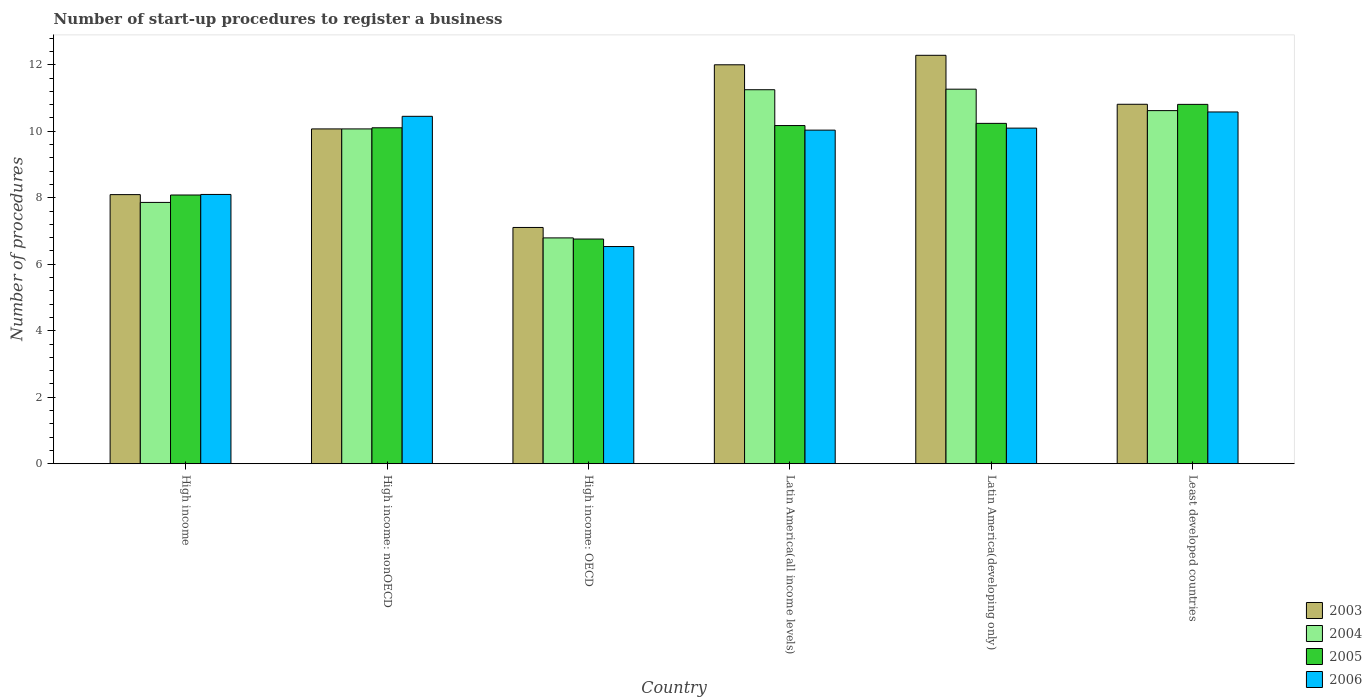How many groups of bars are there?
Offer a terse response. 6. Are the number of bars on each tick of the X-axis equal?
Ensure brevity in your answer.  Yes. How many bars are there on the 5th tick from the left?
Make the answer very short. 4. How many bars are there on the 2nd tick from the right?
Your answer should be very brief. 4. What is the label of the 1st group of bars from the left?
Offer a very short reply. High income. What is the number of procedures required to register a business in 2004 in Latin America(all income levels)?
Give a very brief answer. 11.25. Across all countries, what is the maximum number of procedures required to register a business in 2004?
Your response must be concise. 11.27. Across all countries, what is the minimum number of procedures required to register a business in 2003?
Provide a succinct answer. 7.11. In which country was the number of procedures required to register a business in 2003 maximum?
Provide a short and direct response. Latin America(developing only). In which country was the number of procedures required to register a business in 2003 minimum?
Make the answer very short. High income: OECD. What is the total number of procedures required to register a business in 2004 in the graph?
Offer a very short reply. 57.86. What is the difference between the number of procedures required to register a business in 2004 in High income: nonOECD and that in Least developed countries?
Make the answer very short. -0.55. What is the difference between the number of procedures required to register a business in 2004 in High income: nonOECD and the number of procedures required to register a business in 2003 in Latin America(developing only)?
Your answer should be compact. -2.21. What is the average number of procedures required to register a business in 2003 per country?
Give a very brief answer. 10.06. What is the difference between the number of procedures required to register a business of/in 2003 and number of procedures required to register a business of/in 2004 in High income: OECD?
Your response must be concise. 0.31. What is the ratio of the number of procedures required to register a business in 2003 in Latin America(developing only) to that in Least developed countries?
Offer a terse response. 1.14. What is the difference between the highest and the second highest number of procedures required to register a business in 2006?
Make the answer very short. 0.13. What is the difference between the highest and the lowest number of procedures required to register a business in 2003?
Your answer should be compact. 5.18. In how many countries, is the number of procedures required to register a business in 2004 greater than the average number of procedures required to register a business in 2004 taken over all countries?
Provide a short and direct response. 4. Is the sum of the number of procedures required to register a business in 2005 in High income and High income: OECD greater than the maximum number of procedures required to register a business in 2004 across all countries?
Ensure brevity in your answer.  Yes. What does the 2nd bar from the left in High income: nonOECD represents?
Your answer should be very brief. 2004. Are all the bars in the graph horizontal?
Make the answer very short. No. How many countries are there in the graph?
Provide a short and direct response. 6. What is the difference between two consecutive major ticks on the Y-axis?
Keep it short and to the point. 2. Are the values on the major ticks of Y-axis written in scientific E-notation?
Ensure brevity in your answer.  No. Does the graph contain any zero values?
Provide a short and direct response. No. Where does the legend appear in the graph?
Your answer should be very brief. Bottom right. How many legend labels are there?
Your answer should be compact. 4. What is the title of the graph?
Offer a very short reply. Number of start-up procedures to register a business. Does "1961" appear as one of the legend labels in the graph?
Your response must be concise. No. What is the label or title of the X-axis?
Make the answer very short. Country. What is the label or title of the Y-axis?
Your answer should be compact. Number of procedures. What is the Number of procedures of 2003 in High income?
Offer a very short reply. 8.1. What is the Number of procedures of 2004 in High income?
Keep it short and to the point. 7.86. What is the Number of procedures in 2005 in High income?
Provide a succinct answer. 8.08. What is the Number of procedures in 2006 in High income?
Offer a terse response. 8.1. What is the Number of procedures of 2003 in High income: nonOECD?
Ensure brevity in your answer.  10.07. What is the Number of procedures in 2004 in High income: nonOECD?
Ensure brevity in your answer.  10.07. What is the Number of procedures of 2005 in High income: nonOECD?
Keep it short and to the point. 10.11. What is the Number of procedures in 2006 in High income: nonOECD?
Give a very brief answer. 10.45. What is the Number of procedures in 2003 in High income: OECD?
Provide a succinct answer. 7.11. What is the Number of procedures of 2004 in High income: OECD?
Ensure brevity in your answer.  6.79. What is the Number of procedures in 2005 in High income: OECD?
Provide a short and direct response. 6.76. What is the Number of procedures in 2006 in High income: OECD?
Provide a succinct answer. 6.53. What is the Number of procedures in 2003 in Latin America(all income levels)?
Provide a succinct answer. 12. What is the Number of procedures of 2004 in Latin America(all income levels)?
Provide a succinct answer. 11.25. What is the Number of procedures in 2005 in Latin America(all income levels)?
Your response must be concise. 10.17. What is the Number of procedures in 2006 in Latin America(all income levels)?
Keep it short and to the point. 10.03. What is the Number of procedures of 2003 in Latin America(developing only)?
Your answer should be compact. 12.29. What is the Number of procedures of 2004 in Latin America(developing only)?
Keep it short and to the point. 11.27. What is the Number of procedures of 2005 in Latin America(developing only)?
Keep it short and to the point. 10.24. What is the Number of procedures of 2006 in Latin America(developing only)?
Keep it short and to the point. 10.1. What is the Number of procedures in 2003 in Least developed countries?
Offer a terse response. 10.81. What is the Number of procedures in 2004 in Least developed countries?
Make the answer very short. 10.62. What is the Number of procedures of 2005 in Least developed countries?
Provide a short and direct response. 10.81. What is the Number of procedures in 2006 in Least developed countries?
Provide a short and direct response. 10.58. Across all countries, what is the maximum Number of procedures of 2003?
Provide a succinct answer. 12.29. Across all countries, what is the maximum Number of procedures of 2004?
Keep it short and to the point. 11.27. Across all countries, what is the maximum Number of procedures of 2005?
Give a very brief answer. 10.81. Across all countries, what is the maximum Number of procedures in 2006?
Offer a very short reply. 10.58. Across all countries, what is the minimum Number of procedures in 2003?
Your answer should be compact. 7.11. Across all countries, what is the minimum Number of procedures in 2004?
Offer a very short reply. 6.79. Across all countries, what is the minimum Number of procedures in 2005?
Provide a short and direct response. 6.76. Across all countries, what is the minimum Number of procedures in 2006?
Provide a succinct answer. 6.53. What is the total Number of procedures of 2003 in the graph?
Provide a succinct answer. 60.37. What is the total Number of procedures in 2004 in the graph?
Offer a very short reply. 57.86. What is the total Number of procedures in 2005 in the graph?
Your response must be concise. 56.17. What is the total Number of procedures in 2006 in the graph?
Make the answer very short. 55.79. What is the difference between the Number of procedures in 2003 in High income and that in High income: nonOECD?
Offer a terse response. -1.98. What is the difference between the Number of procedures of 2004 in High income and that in High income: nonOECD?
Your answer should be very brief. -2.21. What is the difference between the Number of procedures of 2005 in High income and that in High income: nonOECD?
Provide a short and direct response. -2.02. What is the difference between the Number of procedures of 2006 in High income and that in High income: nonOECD?
Your answer should be very brief. -2.35. What is the difference between the Number of procedures in 2004 in High income and that in High income: OECD?
Offer a terse response. 1.07. What is the difference between the Number of procedures of 2005 in High income and that in High income: OECD?
Provide a short and direct response. 1.32. What is the difference between the Number of procedures in 2006 in High income and that in High income: OECD?
Your response must be concise. 1.57. What is the difference between the Number of procedures in 2003 in High income and that in Latin America(all income levels)?
Your response must be concise. -3.9. What is the difference between the Number of procedures in 2004 in High income and that in Latin America(all income levels)?
Offer a very short reply. -3.39. What is the difference between the Number of procedures of 2005 in High income and that in Latin America(all income levels)?
Give a very brief answer. -2.09. What is the difference between the Number of procedures in 2006 in High income and that in Latin America(all income levels)?
Give a very brief answer. -1.93. What is the difference between the Number of procedures in 2003 in High income and that in Latin America(developing only)?
Give a very brief answer. -4.19. What is the difference between the Number of procedures of 2004 in High income and that in Latin America(developing only)?
Make the answer very short. -3.41. What is the difference between the Number of procedures in 2005 in High income and that in Latin America(developing only)?
Make the answer very short. -2.15. What is the difference between the Number of procedures of 2006 in High income and that in Latin America(developing only)?
Your answer should be compact. -2. What is the difference between the Number of procedures in 2003 in High income and that in Least developed countries?
Provide a short and direct response. -2.72. What is the difference between the Number of procedures in 2004 in High income and that in Least developed countries?
Your answer should be very brief. -2.76. What is the difference between the Number of procedures of 2005 in High income and that in Least developed countries?
Provide a succinct answer. -2.73. What is the difference between the Number of procedures of 2006 in High income and that in Least developed countries?
Ensure brevity in your answer.  -2.48. What is the difference between the Number of procedures of 2003 in High income: nonOECD and that in High income: OECD?
Provide a short and direct response. 2.96. What is the difference between the Number of procedures in 2004 in High income: nonOECD and that in High income: OECD?
Offer a terse response. 3.28. What is the difference between the Number of procedures of 2005 in High income: nonOECD and that in High income: OECD?
Your answer should be very brief. 3.35. What is the difference between the Number of procedures in 2006 in High income: nonOECD and that in High income: OECD?
Offer a terse response. 3.92. What is the difference between the Number of procedures in 2003 in High income: nonOECD and that in Latin America(all income levels)?
Offer a very short reply. -1.93. What is the difference between the Number of procedures of 2004 in High income: nonOECD and that in Latin America(all income levels)?
Your answer should be compact. -1.18. What is the difference between the Number of procedures in 2005 in High income: nonOECD and that in Latin America(all income levels)?
Your answer should be compact. -0.07. What is the difference between the Number of procedures of 2006 in High income: nonOECD and that in Latin America(all income levels)?
Give a very brief answer. 0.42. What is the difference between the Number of procedures in 2003 in High income: nonOECD and that in Latin America(developing only)?
Give a very brief answer. -2.21. What is the difference between the Number of procedures in 2004 in High income: nonOECD and that in Latin America(developing only)?
Give a very brief answer. -1.2. What is the difference between the Number of procedures of 2005 in High income: nonOECD and that in Latin America(developing only)?
Provide a succinct answer. -0.13. What is the difference between the Number of procedures of 2006 in High income: nonOECD and that in Latin America(developing only)?
Your answer should be compact. 0.35. What is the difference between the Number of procedures of 2003 in High income: nonOECD and that in Least developed countries?
Your response must be concise. -0.74. What is the difference between the Number of procedures in 2004 in High income: nonOECD and that in Least developed countries?
Make the answer very short. -0.55. What is the difference between the Number of procedures of 2005 in High income: nonOECD and that in Least developed countries?
Keep it short and to the point. -0.7. What is the difference between the Number of procedures in 2006 in High income: nonOECD and that in Least developed countries?
Provide a short and direct response. -0.13. What is the difference between the Number of procedures in 2003 in High income: OECD and that in Latin America(all income levels)?
Your response must be concise. -4.89. What is the difference between the Number of procedures in 2004 in High income: OECD and that in Latin America(all income levels)?
Your response must be concise. -4.46. What is the difference between the Number of procedures of 2005 in High income: OECD and that in Latin America(all income levels)?
Your answer should be very brief. -3.41. What is the difference between the Number of procedures of 2006 in High income: OECD and that in Latin America(all income levels)?
Your response must be concise. -3.5. What is the difference between the Number of procedures in 2003 in High income: OECD and that in Latin America(developing only)?
Provide a succinct answer. -5.18. What is the difference between the Number of procedures in 2004 in High income: OECD and that in Latin America(developing only)?
Your answer should be compact. -4.47. What is the difference between the Number of procedures in 2005 in High income: OECD and that in Latin America(developing only)?
Provide a short and direct response. -3.48. What is the difference between the Number of procedures of 2006 in High income: OECD and that in Latin America(developing only)?
Keep it short and to the point. -3.56. What is the difference between the Number of procedures in 2003 in High income: OECD and that in Least developed countries?
Your answer should be very brief. -3.71. What is the difference between the Number of procedures of 2004 in High income: OECD and that in Least developed countries?
Ensure brevity in your answer.  -3.83. What is the difference between the Number of procedures of 2005 in High income: OECD and that in Least developed countries?
Your answer should be very brief. -4.05. What is the difference between the Number of procedures in 2006 in High income: OECD and that in Least developed countries?
Provide a short and direct response. -4.05. What is the difference between the Number of procedures of 2003 in Latin America(all income levels) and that in Latin America(developing only)?
Your response must be concise. -0.29. What is the difference between the Number of procedures of 2004 in Latin America(all income levels) and that in Latin America(developing only)?
Your answer should be compact. -0.02. What is the difference between the Number of procedures of 2005 in Latin America(all income levels) and that in Latin America(developing only)?
Provide a short and direct response. -0.07. What is the difference between the Number of procedures of 2006 in Latin America(all income levels) and that in Latin America(developing only)?
Offer a very short reply. -0.06. What is the difference between the Number of procedures of 2003 in Latin America(all income levels) and that in Least developed countries?
Offer a terse response. 1.19. What is the difference between the Number of procedures in 2004 in Latin America(all income levels) and that in Least developed countries?
Provide a short and direct response. 0.63. What is the difference between the Number of procedures in 2005 in Latin America(all income levels) and that in Least developed countries?
Your response must be concise. -0.64. What is the difference between the Number of procedures of 2006 in Latin America(all income levels) and that in Least developed countries?
Make the answer very short. -0.55. What is the difference between the Number of procedures in 2003 in Latin America(developing only) and that in Least developed countries?
Ensure brevity in your answer.  1.47. What is the difference between the Number of procedures in 2004 in Latin America(developing only) and that in Least developed countries?
Provide a succinct answer. 0.65. What is the difference between the Number of procedures of 2005 in Latin America(developing only) and that in Least developed countries?
Offer a very short reply. -0.57. What is the difference between the Number of procedures of 2006 in Latin America(developing only) and that in Least developed countries?
Offer a very short reply. -0.49. What is the difference between the Number of procedures of 2003 in High income and the Number of procedures of 2004 in High income: nonOECD?
Give a very brief answer. -1.98. What is the difference between the Number of procedures of 2003 in High income and the Number of procedures of 2005 in High income: nonOECD?
Keep it short and to the point. -2.01. What is the difference between the Number of procedures of 2003 in High income and the Number of procedures of 2006 in High income: nonOECD?
Ensure brevity in your answer.  -2.35. What is the difference between the Number of procedures of 2004 in High income and the Number of procedures of 2005 in High income: nonOECD?
Your answer should be very brief. -2.24. What is the difference between the Number of procedures in 2004 in High income and the Number of procedures in 2006 in High income: nonOECD?
Provide a short and direct response. -2.59. What is the difference between the Number of procedures in 2005 in High income and the Number of procedures in 2006 in High income: nonOECD?
Provide a short and direct response. -2.37. What is the difference between the Number of procedures of 2003 in High income and the Number of procedures of 2004 in High income: OECD?
Make the answer very short. 1.3. What is the difference between the Number of procedures of 2003 in High income and the Number of procedures of 2005 in High income: OECD?
Ensure brevity in your answer.  1.34. What is the difference between the Number of procedures of 2003 in High income and the Number of procedures of 2006 in High income: OECD?
Your answer should be compact. 1.56. What is the difference between the Number of procedures of 2004 in High income and the Number of procedures of 2005 in High income: OECD?
Make the answer very short. 1.1. What is the difference between the Number of procedures in 2004 in High income and the Number of procedures in 2006 in High income: OECD?
Your answer should be compact. 1.33. What is the difference between the Number of procedures in 2005 in High income and the Number of procedures in 2006 in High income: OECD?
Ensure brevity in your answer.  1.55. What is the difference between the Number of procedures of 2003 in High income and the Number of procedures of 2004 in Latin America(all income levels)?
Your answer should be compact. -3.15. What is the difference between the Number of procedures of 2003 in High income and the Number of procedures of 2005 in Latin America(all income levels)?
Provide a short and direct response. -2.08. What is the difference between the Number of procedures in 2003 in High income and the Number of procedures in 2006 in Latin America(all income levels)?
Make the answer very short. -1.94. What is the difference between the Number of procedures in 2004 in High income and the Number of procedures in 2005 in Latin America(all income levels)?
Offer a very short reply. -2.31. What is the difference between the Number of procedures of 2004 in High income and the Number of procedures of 2006 in Latin America(all income levels)?
Keep it short and to the point. -2.17. What is the difference between the Number of procedures in 2005 in High income and the Number of procedures in 2006 in Latin America(all income levels)?
Give a very brief answer. -1.95. What is the difference between the Number of procedures of 2003 in High income and the Number of procedures of 2004 in Latin America(developing only)?
Provide a short and direct response. -3.17. What is the difference between the Number of procedures in 2003 in High income and the Number of procedures in 2005 in Latin America(developing only)?
Keep it short and to the point. -2.14. What is the difference between the Number of procedures in 2004 in High income and the Number of procedures in 2005 in Latin America(developing only)?
Your response must be concise. -2.38. What is the difference between the Number of procedures of 2004 in High income and the Number of procedures of 2006 in Latin America(developing only)?
Offer a very short reply. -2.23. What is the difference between the Number of procedures of 2005 in High income and the Number of procedures of 2006 in Latin America(developing only)?
Provide a short and direct response. -2.01. What is the difference between the Number of procedures in 2003 in High income and the Number of procedures in 2004 in Least developed countries?
Make the answer very short. -2.53. What is the difference between the Number of procedures in 2003 in High income and the Number of procedures in 2005 in Least developed countries?
Provide a succinct answer. -2.71. What is the difference between the Number of procedures in 2003 in High income and the Number of procedures in 2006 in Least developed countries?
Ensure brevity in your answer.  -2.49. What is the difference between the Number of procedures in 2004 in High income and the Number of procedures in 2005 in Least developed countries?
Your response must be concise. -2.95. What is the difference between the Number of procedures in 2004 in High income and the Number of procedures in 2006 in Least developed countries?
Keep it short and to the point. -2.72. What is the difference between the Number of procedures in 2005 in High income and the Number of procedures in 2006 in Least developed countries?
Provide a succinct answer. -2.5. What is the difference between the Number of procedures of 2003 in High income: nonOECD and the Number of procedures of 2004 in High income: OECD?
Your answer should be compact. 3.28. What is the difference between the Number of procedures in 2003 in High income: nonOECD and the Number of procedures in 2005 in High income: OECD?
Provide a succinct answer. 3.31. What is the difference between the Number of procedures in 2003 in High income: nonOECD and the Number of procedures in 2006 in High income: OECD?
Keep it short and to the point. 3.54. What is the difference between the Number of procedures of 2004 in High income: nonOECD and the Number of procedures of 2005 in High income: OECD?
Provide a short and direct response. 3.31. What is the difference between the Number of procedures of 2004 in High income: nonOECD and the Number of procedures of 2006 in High income: OECD?
Your response must be concise. 3.54. What is the difference between the Number of procedures of 2005 in High income: nonOECD and the Number of procedures of 2006 in High income: OECD?
Keep it short and to the point. 3.57. What is the difference between the Number of procedures of 2003 in High income: nonOECD and the Number of procedures of 2004 in Latin America(all income levels)?
Your answer should be compact. -1.18. What is the difference between the Number of procedures in 2003 in High income: nonOECD and the Number of procedures in 2005 in Latin America(all income levels)?
Keep it short and to the point. -0.1. What is the difference between the Number of procedures in 2003 in High income: nonOECD and the Number of procedures in 2006 in Latin America(all income levels)?
Provide a succinct answer. 0.04. What is the difference between the Number of procedures in 2004 in High income: nonOECD and the Number of procedures in 2005 in Latin America(all income levels)?
Your response must be concise. -0.1. What is the difference between the Number of procedures of 2004 in High income: nonOECD and the Number of procedures of 2006 in Latin America(all income levels)?
Your answer should be very brief. 0.04. What is the difference between the Number of procedures of 2005 in High income: nonOECD and the Number of procedures of 2006 in Latin America(all income levels)?
Your answer should be compact. 0.07. What is the difference between the Number of procedures of 2003 in High income: nonOECD and the Number of procedures of 2004 in Latin America(developing only)?
Keep it short and to the point. -1.2. What is the difference between the Number of procedures of 2003 in High income: nonOECD and the Number of procedures of 2005 in Latin America(developing only)?
Provide a succinct answer. -0.17. What is the difference between the Number of procedures in 2003 in High income: nonOECD and the Number of procedures in 2006 in Latin America(developing only)?
Give a very brief answer. -0.02. What is the difference between the Number of procedures of 2004 in High income: nonOECD and the Number of procedures of 2006 in Latin America(developing only)?
Keep it short and to the point. -0.02. What is the difference between the Number of procedures of 2003 in High income: nonOECD and the Number of procedures of 2004 in Least developed countries?
Make the answer very short. -0.55. What is the difference between the Number of procedures of 2003 in High income: nonOECD and the Number of procedures of 2005 in Least developed countries?
Provide a succinct answer. -0.74. What is the difference between the Number of procedures in 2003 in High income: nonOECD and the Number of procedures in 2006 in Least developed countries?
Keep it short and to the point. -0.51. What is the difference between the Number of procedures of 2004 in High income: nonOECD and the Number of procedures of 2005 in Least developed countries?
Your answer should be compact. -0.74. What is the difference between the Number of procedures of 2004 in High income: nonOECD and the Number of procedures of 2006 in Least developed countries?
Keep it short and to the point. -0.51. What is the difference between the Number of procedures of 2005 in High income: nonOECD and the Number of procedures of 2006 in Least developed countries?
Offer a terse response. -0.48. What is the difference between the Number of procedures of 2003 in High income: OECD and the Number of procedures of 2004 in Latin America(all income levels)?
Your response must be concise. -4.14. What is the difference between the Number of procedures of 2003 in High income: OECD and the Number of procedures of 2005 in Latin America(all income levels)?
Your answer should be very brief. -3.07. What is the difference between the Number of procedures in 2003 in High income: OECD and the Number of procedures in 2006 in Latin America(all income levels)?
Offer a terse response. -2.93. What is the difference between the Number of procedures of 2004 in High income: OECD and the Number of procedures of 2005 in Latin America(all income levels)?
Give a very brief answer. -3.38. What is the difference between the Number of procedures of 2004 in High income: OECD and the Number of procedures of 2006 in Latin America(all income levels)?
Make the answer very short. -3.24. What is the difference between the Number of procedures of 2005 in High income: OECD and the Number of procedures of 2006 in Latin America(all income levels)?
Your answer should be compact. -3.28. What is the difference between the Number of procedures in 2003 in High income: OECD and the Number of procedures in 2004 in Latin America(developing only)?
Offer a very short reply. -4.16. What is the difference between the Number of procedures in 2003 in High income: OECD and the Number of procedures in 2005 in Latin America(developing only)?
Offer a very short reply. -3.13. What is the difference between the Number of procedures in 2003 in High income: OECD and the Number of procedures in 2006 in Latin America(developing only)?
Offer a very short reply. -2.99. What is the difference between the Number of procedures in 2004 in High income: OECD and the Number of procedures in 2005 in Latin America(developing only)?
Provide a short and direct response. -3.44. What is the difference between the Number of procedures in 2004 in High income: OECD and the Number of procedures in 2006 in Latin America(developing only)?
Give a very brief answer. -3.3. What is the difference between the Number of procedures in 2005 in High income: OECD and the Number of procedures in 2006 in Latin America(developing only)?
Ensure brevity in your answer.  -3.34. What is the difference between the Number of procedures of 2003 in High income: OECD and the Number of procedures of 2004 in Least developed countries?
Your answer should be compact. -3.51. What is the difference between the Number of procedures in 2003 in High income: OECD and the Number of procedures in 2005 in Least developed countries?
Give a very brief answer. -3.7. What is the difference between the Number of procedures of 2003 in High income: OECD and the Number of procedures of 2006 in Least developed countries?
Provide a succinct answer. -3.47. What is the difference between the Number of procedures in 2004 in High income: OECD and the Number of procedures in 2005 in Least developed countries?
Your response must be concise. -4.02. What is the difference between the Number of procedures in 2004 in High income: OECD and the Number of procedures in 2006 in Least developed countries?
Keep it short and to the point. -3.79. What is the difference between the Number of procedures in 2005 in High income: OECD and the Number of procedures in 2006 in Least developed countries?
Offer a terse response. -3.82. What is the difference between the Number of procedures in 2003 in Latin America(all income levels) and the Number of procedures in 2004 in Latin America(developing only)?
Keep it short and to the point. 0.73. What is the difference between the Number of procedures in 2003 in Latin America(all income levels) and the Number of procedures in 2005 in Latin America(developing only)?
Ensure brevity in your answer.  1.76. What is the difference between the Number of procedures in 2003 in Latin America(all income levels) and the Number of procedures in 2006 in Latin America(developing only)?
Provide a succinct answer. 1.9. What is the difference between the Number of procedures in 2004 in Latin America(all income levels) and the Number of procedures in 2005 in Latin America(developing only)?
Make the answer very short. 1.01. What is the difference between the Number of procedures in 2004 in Latin America(all income levels) and the Number of procedures in 2006 in Latin America(developing only)?
Provide a short and direct response. 1.15. What is the difference between the Number of procedures in 2005 in Latin America(all income levels) and the Number of procedures in 2006 in Latin America(developing only)?
Give a very brief answer. 0.08. What is the difference between the Number of procedures in 2003 in Latin America(all income levels) and the Number of procedures in 2004 in Least developed countries?
Your answer should be very brief. 1.38. What is the difference between the Number of procedures in 2003 in Latin America(all income levels) and the Number of procedures in 2005 in Least developed countries?
Keep it short and to the point. 1.19. What is the difference between the Number of procedures of 2003 in Latin America(all income levels) and the Number of procedures of 2006 in Least developed countries?
Make the answer very short. 1.42. What is the difference between the Number of procedures in 2004 in Latin America(all income levels) and the Number of procedures in 2005 in Least developed countries?
Offer a very short reply. 0.44. What is the difference between the Number of procedures in 2004 in Latin America(all income levels) and the Number of procedures in 2006 in Least developed countries?
Make the answer very short. 0.67. What is the difference between the Number of procedures of 2005 in Latin America(all income levels) and the Number of procedures of 2006 in Least developed countries?
Offer a very short reply. -0.41. What is the difference between the Number of procedures of 2003 in Latin America(developing only) and the Number of procedures of 2004 in Least developed countries?
Provide a succinct answer. 1.66. What is the difference between the Number of procedures of 2003 in Latin America(developing only) and the Number of procedures of 2005 in Least developed countries?
Provide a short and direct response. 1.48. What is the difference between the Number of procedures of 2003 in Latin America(developing only) and the Number of procedures of 2006 in Least developed countries?
Your response must be concise. 1.7. What is the difference between the Number of procedures in 2004 in Latin America(developing only) and the Number of procedures in 2005 in Least developed countries?
Keep it short and to the point. 0.46. What is the difference between the Number of procedures of 2004 in Latin America(developing only) and the Number of procedures of 2006 in Least developed countries?
Your answer should be very brief. 0.69. What is the difference between the Number of procedures in 2005 in Latin America(developing only) and the Number of procedures in 2006 in Least developed countries?
Ensure brevity in your answer.  -0.34. What is the average Number of procedures of 2003 per country?
Offer a very short reply. 10.06. What is the average Number of procedures of 2004 per country?
Keep it short and to the point. 9.64. What is the average Number of procedures in 2005 per country?
Keep it short and to the point. 9.36. What is the average Number of procedures in 2006 per country?
Provide a succinct answer. 9.3. What is the difference between the Number of procedures of 2003 and Number of procedures of 2004 in High income?
Provide a succinct answer. 0.23. What is the difference between the Number of procedures in 2003 and Number of procedures in 2005 in High income?
Provide a succinct answer. 0.01. What is the difference between the Number of procedures in 2003 and Number of procedures in 2006 in High income?
Give a very brief answer. -0. What is the difference between the Number of procedures of 2004 and Number of procedures of 2005 in High income?
Keep it short and to the point. -0.22. What is the difference between the Number of procedures of 2004 and Number of procedures of 2006 in High income?
Your answer should be compact. -0.24. What is the difference between the Number of procedures in 2005 and Number of procedures in 2006 in High income?
Ensure brevity in your answer.  -0.02. What is the difference between the Number of procedures in 2003 and Number of procedures in 2004 in High income: nonOECD?
Provide a succinct answer. 0. What is the difference between the Number of procedures of 2003 and Number of procedures of 2005 in High income: nonOECD?
Ensure brevity in your answer.  -0.03. What is the difference between the Number of procedures in 2003 and Number of procedures in 2006 in High income: nonOECD?
Ensure brevity in your answer.  -0.38. What is the difference between the Number of procedures in 2004 and Number of procedures in 2005 in High income: nonOECD?
Ensure brevity in your answer.  -0.03. What is the difference between the Number of procedures of 2004 and Number of procedures of 2006 in High income: nonOECD?
Provide a short and direct response. -0.38. What is the difference between the Number of procedures of 2005 and Number of procedures of 2006 in High income: nonOECD?
Provide a short and direct response. -0.34. What is the difference between the Number of procedures in 2003 and Number of procedures in 2004 in High income: OECD?
Keep it short and to the point. 0.31. What is the difference between the Number of procedures in 2003 and Number of procedures in 2005 in High income: OECD?
Your response must be concise. 0.35. What is the difference between the Number of procedures of 2003 and Number of procedures of 2006 in High income: OECD?
Your answer should be very brief. 0.57. What is the difference between the Number of procedures in 2004 and Number of procedures in 2005 in High income: OECD?
Ensure brevity in your answer.  0.03. What is the difference between the Number of procedures of 2004 and Number of procedures of 2006 in High income: OECD?
Make the answer very short. 0.26. What is the difference between the Number of procedures in 2005 and Number of procedures in 2006 in High income: OECD?
Ensure brevity in your answer.  0.23. What is the difference between the Number of procedures in 2003 and Number of procedures in 2004 in Latin America(all income levels)?
Ensure brevity in your answer.  0.75. What is the difference between the Number of procedures in 2003 and Number of procedures in 2005 in Latin America(all income levels)?
Ensure brevity in your answer.  1.83. What is the difference between the Number of procedures in 2003 and Number of procedures in 2006 in Latin America(all income levels)?
Provide a succinct answer. 1.97. What is the difference between the Number of procedures of 2004 and Number of procedures of 2005 in Latin America(all income levels)?
Offer a terse response. 1.08. What is the difference between the Number of procedures in 2004 and Number of procedures in 2006 in Latin America(all income levels)?
Make the answer very short. 1.22. What is the difference between the Number of procedures in 2005 and Number of procedures in 2006 in Latin America(all income levels)?
Your answer should be compact. 0.14. What is the difference between the Number of procedures in 2003 and Number of procedures in 2004 in Latin America(developing only)?
Provide a short and direct response. 1.02. What is the difference between the Number of procedures in 2003 and Number of procedures in 2005 in Latin America(developing only)?
Offer a very short reply. 2.05. What is the difference between the Number of procedures of 2003 and Number of procedures of 2006 in Latin America(developing only)?
Provide a short and direct response. 2.19. What is the difference between the Number of procedures in 2004 and Number of procedures in 2005 in Latin America(developing only)?
Offer a very short reply. 1.03. What is the difference between the Number of procedures of 2004 and Number of procedures of 2006 in Latin America(developing only)?
Make the answer very short. 1.17. What is the difference between the Number of procedures of 2005 and Number of procedures of 2006 in Latin America(developing only)?
Your answer should be very brief. 0.14. What is the difference between the Number of procedures of 2003 and Number of procedures of 2004 in Least developed countries?
Give a very brief answer. 0.19. What is the difference between the Number of procedures in 2003 and Number of procedures in 2005 in Least developed countries?
Your answer should be compact. 0. What is the difference between the Number of procedures in 2003 and Number of procedures in 2006 in Least developed countries?
Provide a succinct answer. 0.23. What is the difference between the Number of procedures in 2004 and Number of procedures in 2005 in Least developed countries?
Give a very brief answer. -0.19. What is the difference between the Number of procedures in 2004 and Number of procedures in 2006 in Least developed countries?
Provide a succinct answer. 0.04. What is the difference between the Number of procedures of 2005 and Number of procedures of 2006 in Least developed countries?
Provide a succinct answer. 0.23. What is the ratio of the Number of procedures of 2003 in High income to that in High income: nonOECD?
Your response must be concise. 0.8. What is the ratio of the Number of procedures in 2004 in High income to that in High income: nonOECD?
Ensure brevity in your answer.  0.78. What is the ratio of the Number of procedures in 2005 in High income to that in High income: nonOECD?
Your response must be concise. 0.8. What is the ratio of the Number of procedures of 2006 in High income to that in High income: nonOECD?
Keep it short and to the point. 0.78. What is the ratio of the Number of procedures of 2003 in High income to that in High income: OECD?
Offer a terse response. 1.14. What is the ratio of the Number of procedures of 2004 in High income to that in High income: OECD?
Provide a succinct answer. 1.16. What is the ratio of the Number of procedures of 2005 in High income to that in High income: OECD?
Your answer should be compact. 1.2. What is the ratio of the Number of procedures of 2006 in High income to that in High income: OECD?
Provide a succinct answer. 1.24. What is the ratio of the Number of procedures of 2003 in High income to that in Latin America(all income levels)?
Your answer should be very brief. 0.67. What is the ratio of the Number of procedures in 2004 in High income to that in Latin America(all income levels)?
Make the answer very short. 0.7. What is the ratio of the Number of procedures in 2005 in High income to that in Latin America(all income levels)?
Offer a very short reply. 0.79. What is the ratio of the Number of procedures of 2006 in High income to that in Latin America(all income levels)?
Offer a terse response. 0.81. What is the ratio of the Number of procedures of 2003 in High income to that in Latin America(developing only)?
Your answer should be very brief. 0.66. What is the ratio of the Number of procedures in 2004 in High income to that in Latin America(developing only)?
Offer a terse response. 0.7. What is the ratio of the Number of procedures in 2005 in High income to that in Latin America(developing only)?
Provide a short and direct response. 0.79. What is the ratio of the Number of procedures in 2006 in High income to that in Latin America(developing only)?
Provide a succinct answer. 0.8. What is the ratio of the Number of procedures in 2003 in High income to that in Least developed countries?
Ensure brevity in your answer.  0.75. What is the ratio of the Number of procedures of 2004 in High income to that in Least developed countries?
Make the answer very short. 0.74. What is the ratio of the Number of procedures in 2005 in High income to that in Least developed countries?
Keep it short and to the point. 0.75. What is the ratio of the Number of procedures of 2006 in High income to that in Least developed countries?
Your answer should be compact. 0.77. What is the ratio of the Number of procedures of 2003 in High income: nonOECD to that in High income: OECD?
Provide a succinct answer. 1.42. What is the ratio of the Number of procedures of 2004 in High income: nonOECD to that in High income: OECD?
Make the answer very short. 1.48. What is the ratio of the Number of procedures in 2005 in High income: nonOECD to that in High income: OECD?
Your answer should be compact. 1.5. What is the ratio of the Number of procedures of 2006 in High income: nonOECD to that in High income: OECD?
Keep it short and to the point. 1.6. What is the ratio of the Number of procedures in 2003 in High income: nonOECD to that in Latin America(all income levels)?
Your answer should be compact. 0.84. What is the ratio of the Number of procedures of 2004 in High income: nonOECD to that in Latin America(all income levels)?
Your answer should be compact. 0.9. What is the ratio of the Number of procedures in 2006 in High income: nonOECD to that in Latin America(all income levels)?
Make the answer very short. 1.04. What is the ratio of the Number of procedures in 2003 in High income: nonOECD to that in Latin America(developing only)?
Ensure brevity in your answer.  0.82. What is the ratio of the Number of procedures in 2004 in High income: nonOECD to that in Latin America(developing only)?
Keep it short and to the point. 0.89. What is the ratio of the Number of procedures in 2005 in High income: nonOECD to that in Latin America(developing only)?
Give a very brief answer. 0.99. What is the ratio of the Number of procedures in 2006 in High income: nonOECD to that in Latin America(developing only)?
Keep it short and to the point. 1.04. What is the ratio of the Number of procedures in 2003 in High income: nonOECD to that in Least developed countries?
Offer a terse response. 0.93. What is the ratio of the Number of procedures in 2004 in High income: nonOECD to that in Least developed countries?
Provide a short and direct response. 0.95. What is the ratio of the Number of procedures of 2005 in High income: nonOECD to that in Least developed countries?
Give a very brief answer. 0.93. What is the ratio of the Number of procedures of 2006 in High income: nonOECD to that in Least developed countries?
Offer a very short reply. 0.99. What is the ratio of the Number of procedures in 2003 in High income: OECD to that in Latin America(all income levels)?
Offer a terse response. 0.59. What is the ratio of the Number of procedures of 2004 in High income: OECD to that in Latin America(all income levels)?
Your response must be concise. 0.6. What is the ratio of the Number of procedures of 2005 in High income: OECD to that in Latin America(all income levels)?
Give a very brief answer. 0.66. What is the ratio of the Number of procedures of 2006 in High income: OECD to that in Latin America(all income levels)?
Give a very brief answer. 0.65. What is the ratio of the Number of procedures in 2003 in High income: OECD to that in Latin America(developing only)?
Your response must be concise. 0.58. What is the ratio of the Number of procedures in 2004 in High income: OECD to that in Latin America(developing only)?
Keep it short and to the point. 0.6. What is the ratio of the Number of procedures in 2005 in High income: OECD to that in Latin America(developing only)?
Ensure brevity in your answer.  0.66. What is the ratio of the Number of procedures of 2006 in High income: OECD to that in Latin America(developing only)?
Your response must be concise. 0.65. What is the ratio of the Number of procedures in 2003 in High income: OECD to that in Least developed countries?
Provide a succinct answer. 0.66. What is the ratio of the Number of procedures in 2004 in High income: OECD to that in Least developed countries?
Offer a terse response. 0.64. What is the ratio of the Number of procedures of 2005 in High income: OECD to that in Least developed countries?
Your answer should be very brief. 0.63. What is the ratio of the Number of procedures in 2006 in High income: OECD to that in Least developed countries?
Offer a very short reply. 0.62. What is the ratio of the Number of procedures in 2003 in Latin America(all income levels) to that in Latin America(developing only)?
Provide a succinct answer. 0.98. What is the ratio of the Number of procedures in 2006 in Latin America(all income levels) to that in Latin America(developing only)?
Make the answer very short. 0.99. What is the ratio of the Number of procedures in 2003 in Latin America(all income levels) to that in Least developed countries?
Give a very brief answer. 1.11. What is the ratio of the Number of procedures of 2004 in Latin America(all income levels) to that in Least developed countries?
Make the answer very short. 1.06. What is the ratio of the Number of procedures in 2005 in Latin America(all income levels) to that in Least developed countries?
Give a very brief answer. 0.94. What is the ratio of the Number of procedures of 2006 in Latin America(all income levels) to that in Least developed countries?
Make the answer very short. 0.95. What is the ratio of the Number of procedures of 2003 in Latin America(developing only) to that in Least developed countries?
Keep it short and to the point. 1.14. What is the ratio of the Number of procedures of 2004 in Latin America(developing only) to that in Least developed countries?
Give a very brief answer. 1.06. What is the ratio of the Number of procedures in 2005 in Latin America(developing only) to that in Least developed countries?
Keep it short and to the point. 0.95. What is the ratio of the Number of procedures of 2006 in Latin America(developing only) to that in Least developed countries?
Give a very brief answer. 0.95. What is the difference between the highest and the second highest Number of procedures of 2003?
Offer a terse response. 0.29. What is the difference between the highest and the second highest Number of procedures in 2004?
Offer a terse response. 0.02. What is the difference between the highest and the second highest Number of procedures in 2005?
Provide a short and direct response. 0.57. What is the difference between the highest and the second highest Number of procedures of 2006?
Your answer should be compact. 0.13. What is the difference between the highest and the lowest Number of procedures in 2003?
Provide a short and direct response. 5.18. What is the difference between the highest and the lowest Number of procedures in 2004?
Offer a terse response. 4.47. What is the difference between the highest and the lowest Number of procedures in 2005?
Keep it short and to the point. 4.05. What is the difference between the highest and the lowest Number of procedures in 2006?
Make the answer very short. 4.05. 